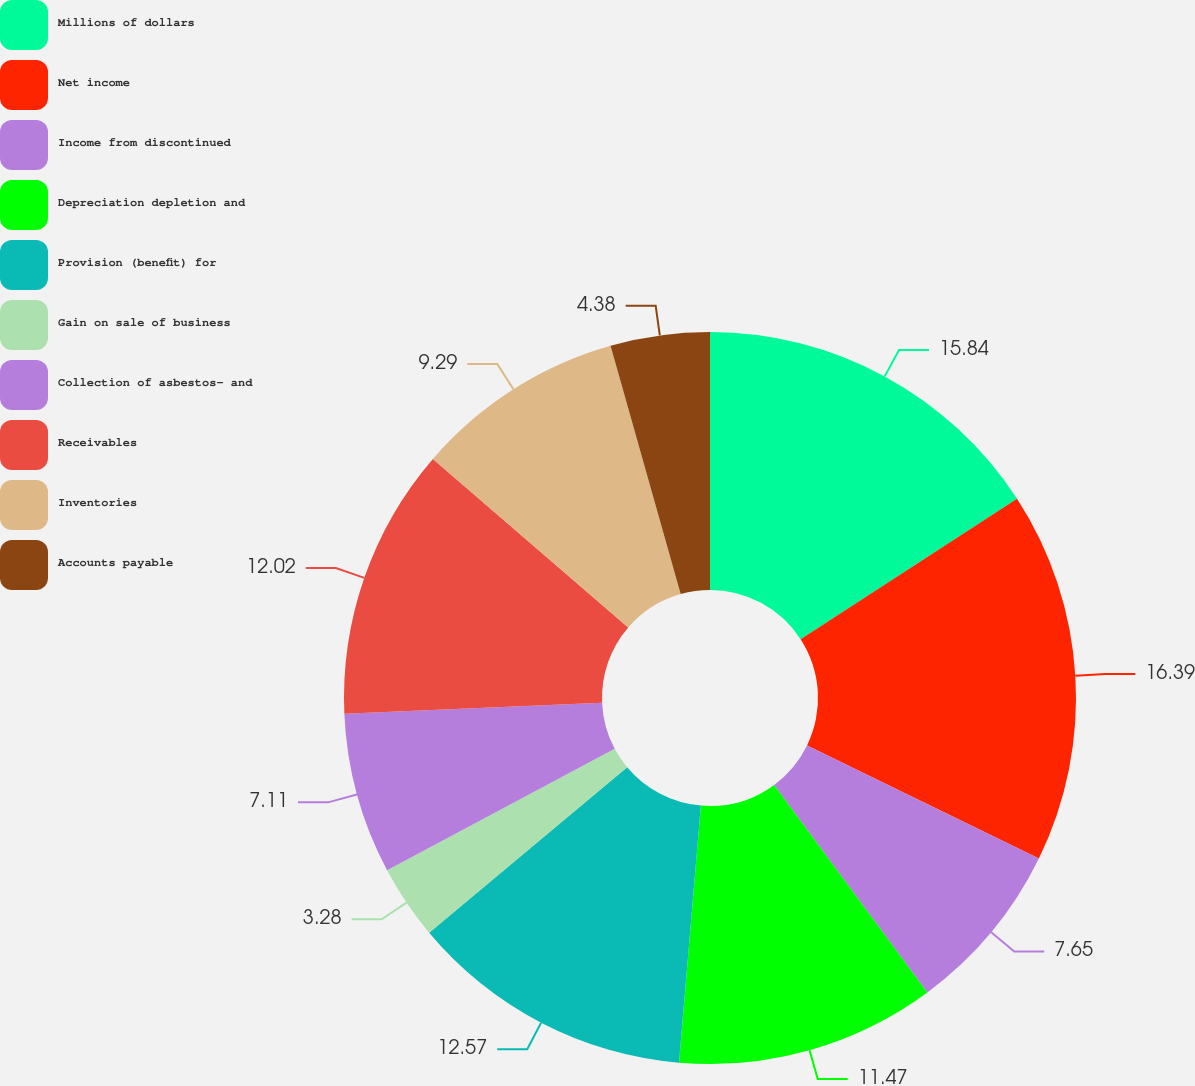Convert chart to OTSL. <chart><loc_0><loc_0><loc_500><loc_500><pie_chart><fcel>Millions of dollars<fcel>Net income<fcel>Income from discontinued<fcel>Depreciation depletion and<fcel>Provision (benefit) for<fcel>Gain on sale of business<fcel>Collection of asbestos- and<fcel>Receivables<fcel>Inventories<fcel>Accounts payable<nl><fcel>15.84%<fcel>16.39%<fcel>7.65%<fcel>11.47%<fcel>12.57%<fcel>3.28%<fcel>7.11%<fcel>12.02%<fcel>9.29%<fcel>4.38%<nl></chart> 